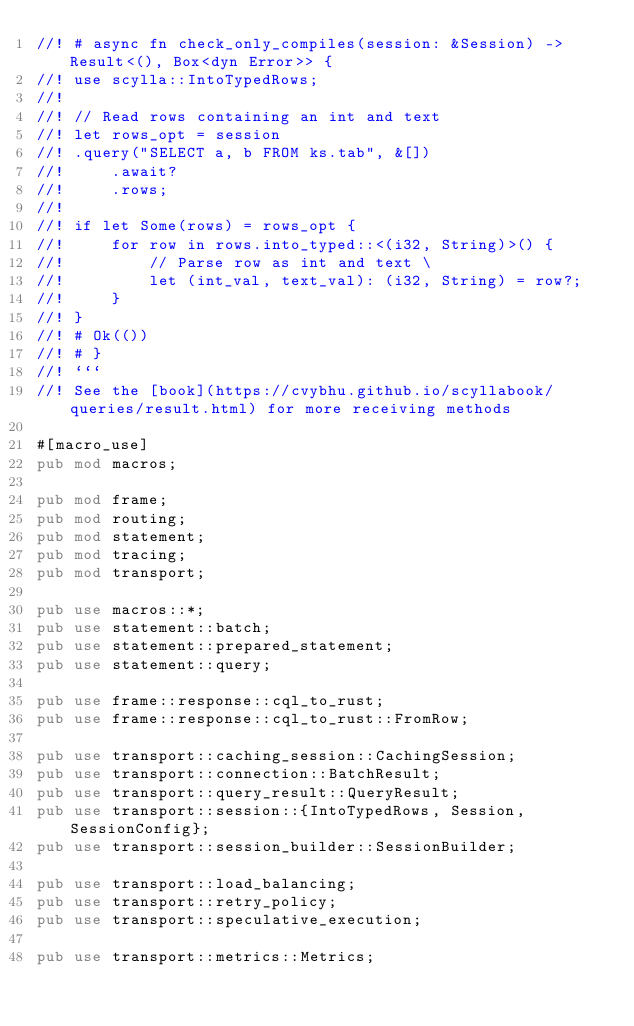Convert code to text. <code><loc_0><loc_0><loc_500><loc_500><_Rust_>//! # async fn check_only_compiles(session: &Session) -> Result<(), Box<dyn Error>> {
//! use scylla::IntoTypedRows;
//!
//! // Read rows containing an int and text
//! let rows_opt = session
//! .query("SELECT a, b FROM ks.tab", &[])
//!     .await?
//!     .rows;
//!
//! if let Some(rows) = rows_opt {
//!     for row in rows.into_typed::<(i32, String)>() {
//!         // Parse row as int and text \
//!         let (int_val, text_val): (i32, String) = row?;
//!     }
//! }
//! # Ok(())
//! # }
//! ```
//! See the [book](https://cvybhu.github.io/scyllabook/queries/result.html) for more receiving methods

#[macro_use]
pub mod macros;

pub mod frame;
pub mod routing;
pub mod statement;
pub mod tracing;
pub mod transport;

pub use macros::*;
pub use statement::batch;
pub use statement::prepared_statement;
pub use statement::query;

pub use frame::response::cql_to_rust;
pub use frame::response::cql_to_rust::FromRow;

pub use transport::caching_session::CachingSession;
pub use transport::connection::BatchResult;
pub use transport::query_result::QueryResult;
pub use transport::session::{IntoTypedRows, Session, SessionConfig};
pub use transport::session_builder::SessionBuilder;

pub use transport::load_balancing;
pub use transport::retry_policy;
pub use transport::speculative_execution;

pub use transport::metrics::Metrics;
</code> 